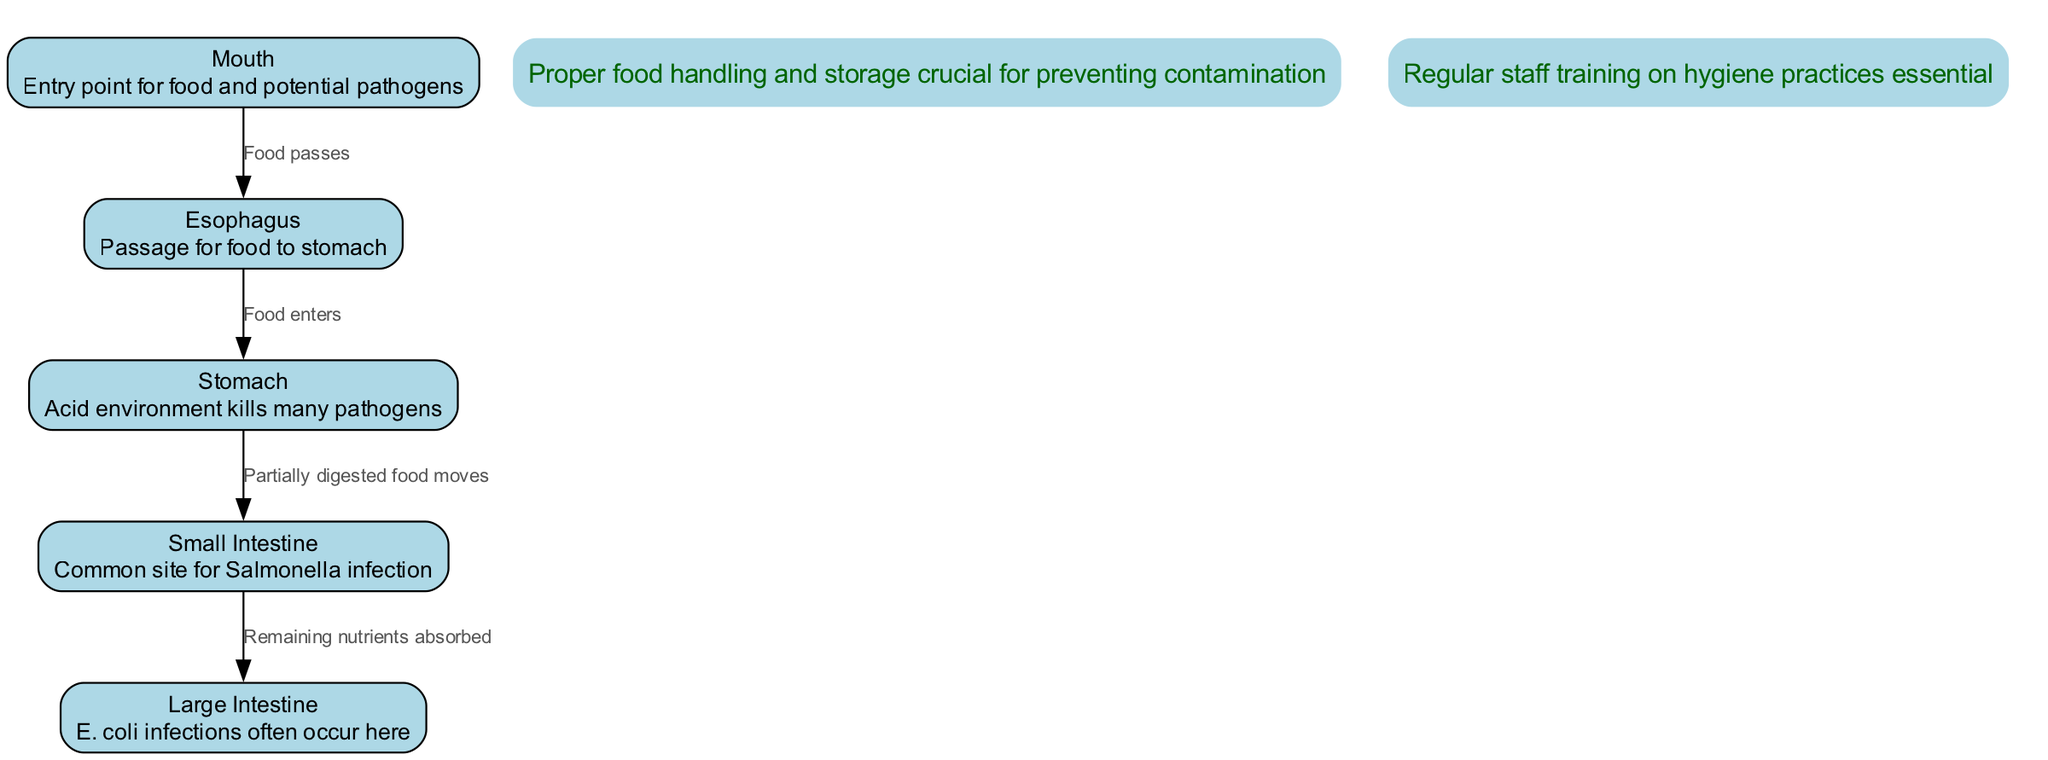What are the main entry points for pathogens in the digestive system? The primary entry point for pathogens in the digestive system is the mouth. Pathogens can also enter through food that passes down the esophagus. Thus, the mouth is the main entry point.
Answer: Mouth How many areas in the digestive system are highlighted as common infection sites? The diagram highlights two areas commonly affected by pathogens: the small intestine and the large intestine. This count is derived directly from the descriptions provided for these specific nodes.
Answer: Two What is the description of the stomach? The stomach is described as having an acid environment that kills many pathogens. This information is specifically included in the description of the stomach node in the diagram.
Answer: Acid environment kills many pathogens What type of infection primarily occurs in the small intestine? The diagram specifies Salmonella as the primary infection that commonly occurs in the small intestine. This information is explicitly stated in the description node for the small intestine.
Answer: Salmonella What role does the esophagus play in digestion? The esophagus serves as the passage for food to the stomach, according to the diagram. The function of the esophagus is clearly defined in its description node, emphasizing its role in the digestive process.
Answer: Passage for food to stomach Which type of bacteria infections frequently occur in the large intestine? The diagram identifies E. coli infections as frequently occurring in the large intestine. This detail is provided in the description of the large intestine node.
Answer: E. coli Why is proper food handling and storage important? Proper food handling and storage are crucial for preventing contamination of food, as noted in the annotation at the top of the diagram. This highlights the importance of these practices in the context of food safety.
Answer: Preventing contamination What is one of the annotations regarding staff training? The annotation states that regular staff training on hygiene practices is essential. This information emphasizes the importance of proper hygiene in restaurant operations to prevent foodborne illnesses.
Answer: Regular staff training on hygiene practices essential How does food move from the stomach to the small intestine? The diagram shows that partially digested food moves from the stomach to the small intestine. This movement is indicated by the directed edge connecting the stomach and small intestine nodes in the diagram.
Answer: Partially digested food moves 